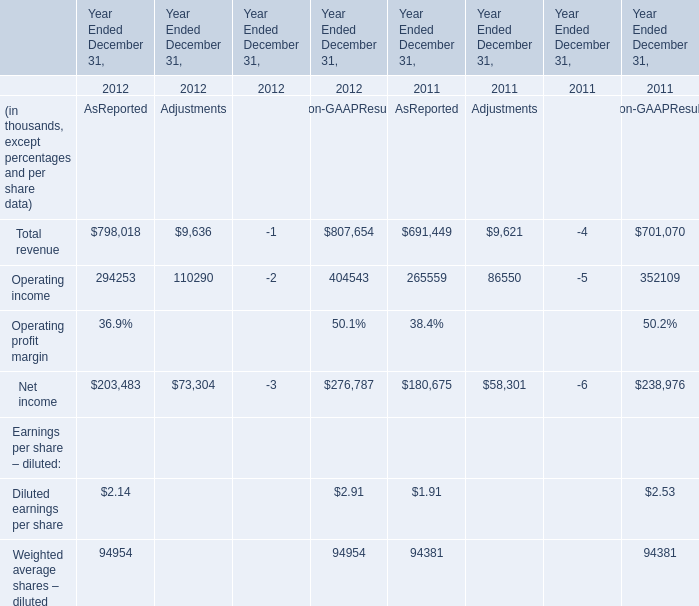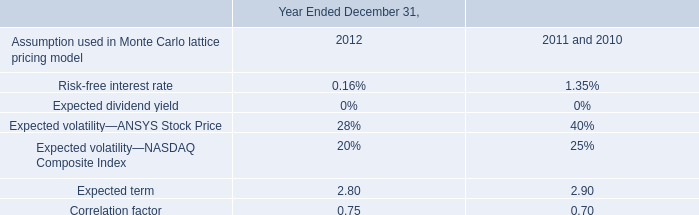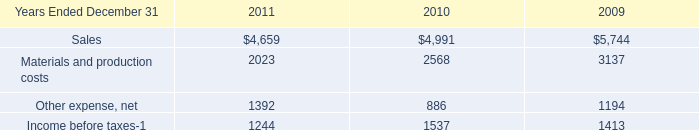What's the sum of Materials and production costs of 2010, and Net income of Year Ended December 31, 2011 AsReported ? 
Computations: (2568.0 + 180675.0)
Answer: 183243.0. 